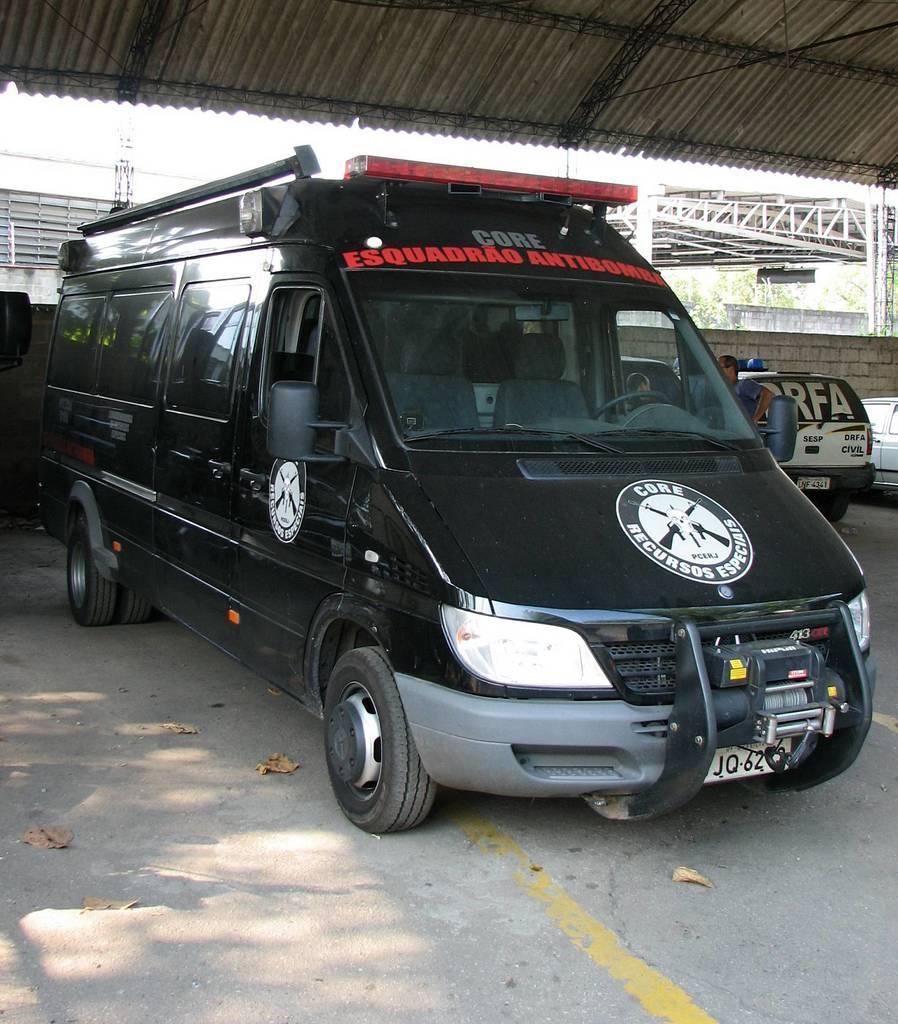How would you summarize this image in a sentence or two? There are vehicles and some persons are standing in the middle of this image. We can see a shelter at the top of this image. 